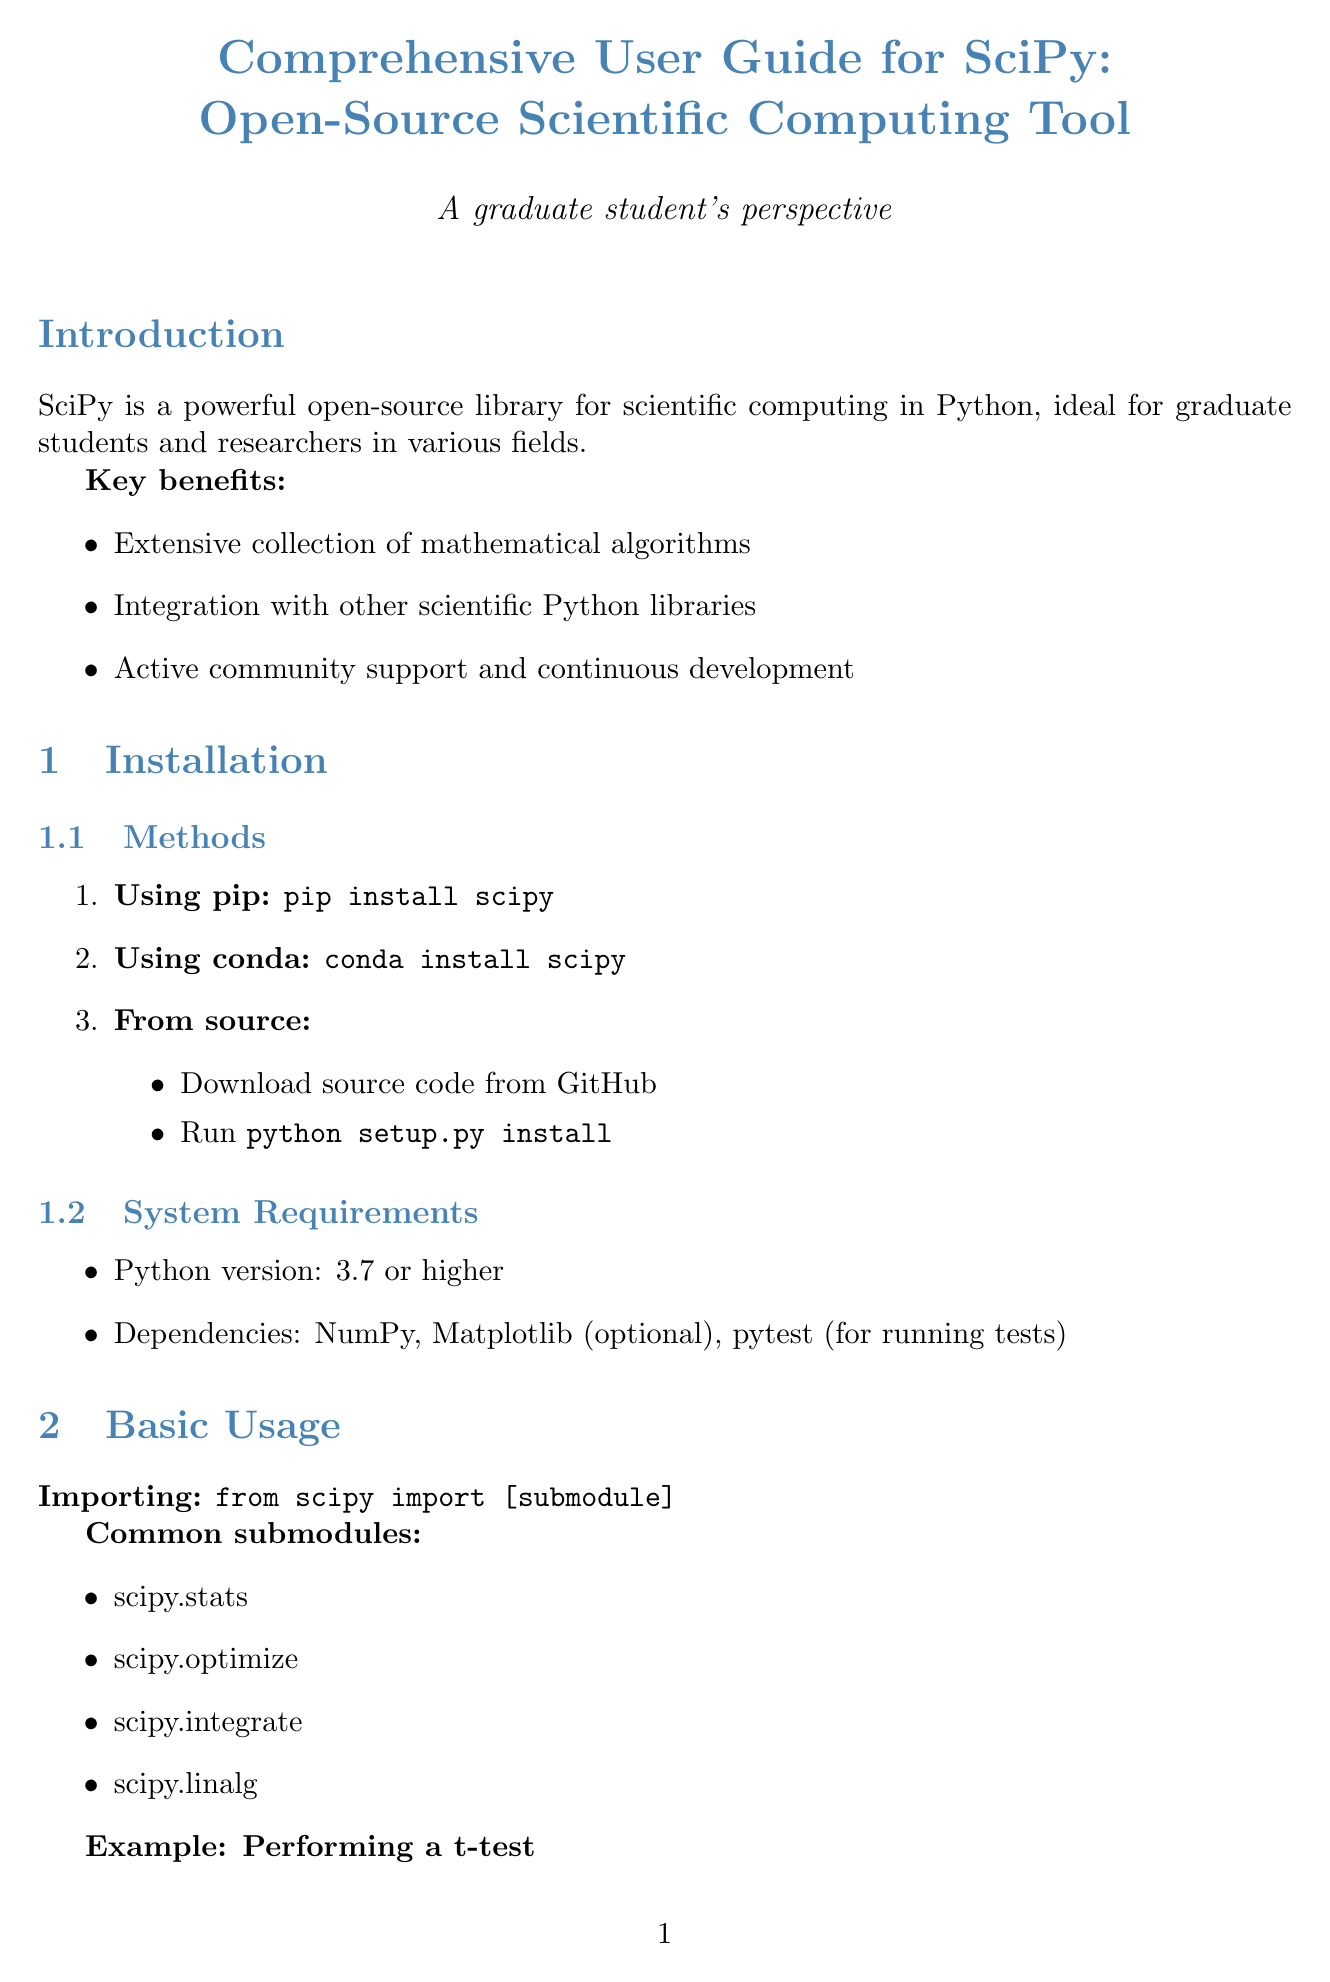What are the key benefits of using SciPy? The benefits listed in the document include an extensive collection of mathematical algorithms, integration with other scientific Python libraries, and active community support and continuous development.
Answer: Extensive collection of mathematical algorithms, Integration with other scientific Python libraries, Active community support and continuous development What command is used to install SciPy using pip? The document specifies that the command for installing SciPy with pip is 'pip install scipy'.
Answer: pip install scipy Which Python version is required for SciPy? The system requirements state that a Python version of 3.7 or higher is required for using SciPy.
Answer: 3.7 or higher Name a submodule in SciPy used for optimization. One of the common submodules mentioned in the document for optimization is 'scipy.optimize'.
Answer: scipy.optimize What is the purpose of the function scipy.stats.ttest_ind? The document describes the function's purpose as calculating the T-test for the means of two independent samples of scores.
Answer: Calculate the T-test for the means of two independent samples of scores What should you do if you encounter an ImportError for SciPy? The troubleshooting section provides the solution to ensure SciPy is properly installed and in your Python path if you face an ImportError.
Answer: Ensure SciPy is properly installed and in your Python path How can users contribute to the SciPy project? The ways to contribute include reporting bugs, suggesting enhancements, writing documentation, and submitting pull requests.
Answer: Reporting bugs, suggesting enhancements, writing documentation, submitting pull requests What type of issues are addressed in the troubleshooting section? The common issues mentioned in the troubleshooting section include import errors and memory errors when working with large datasets.
Answer: Import errors, memory errors when working with large datasets 